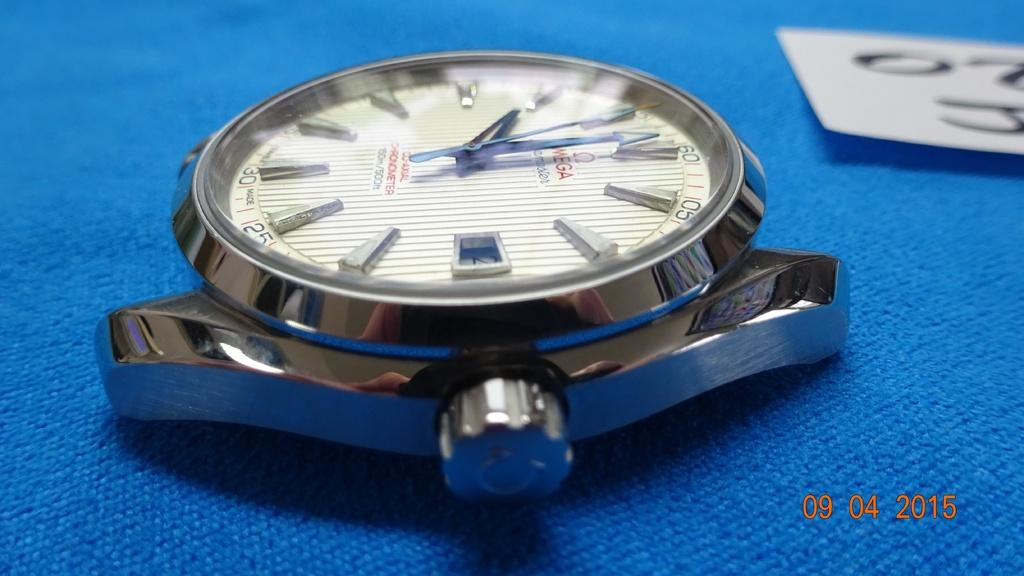<image>
Share a concise interpretation of the image provided. A photo taken on September 4th, 2015 of a strapless watch. 